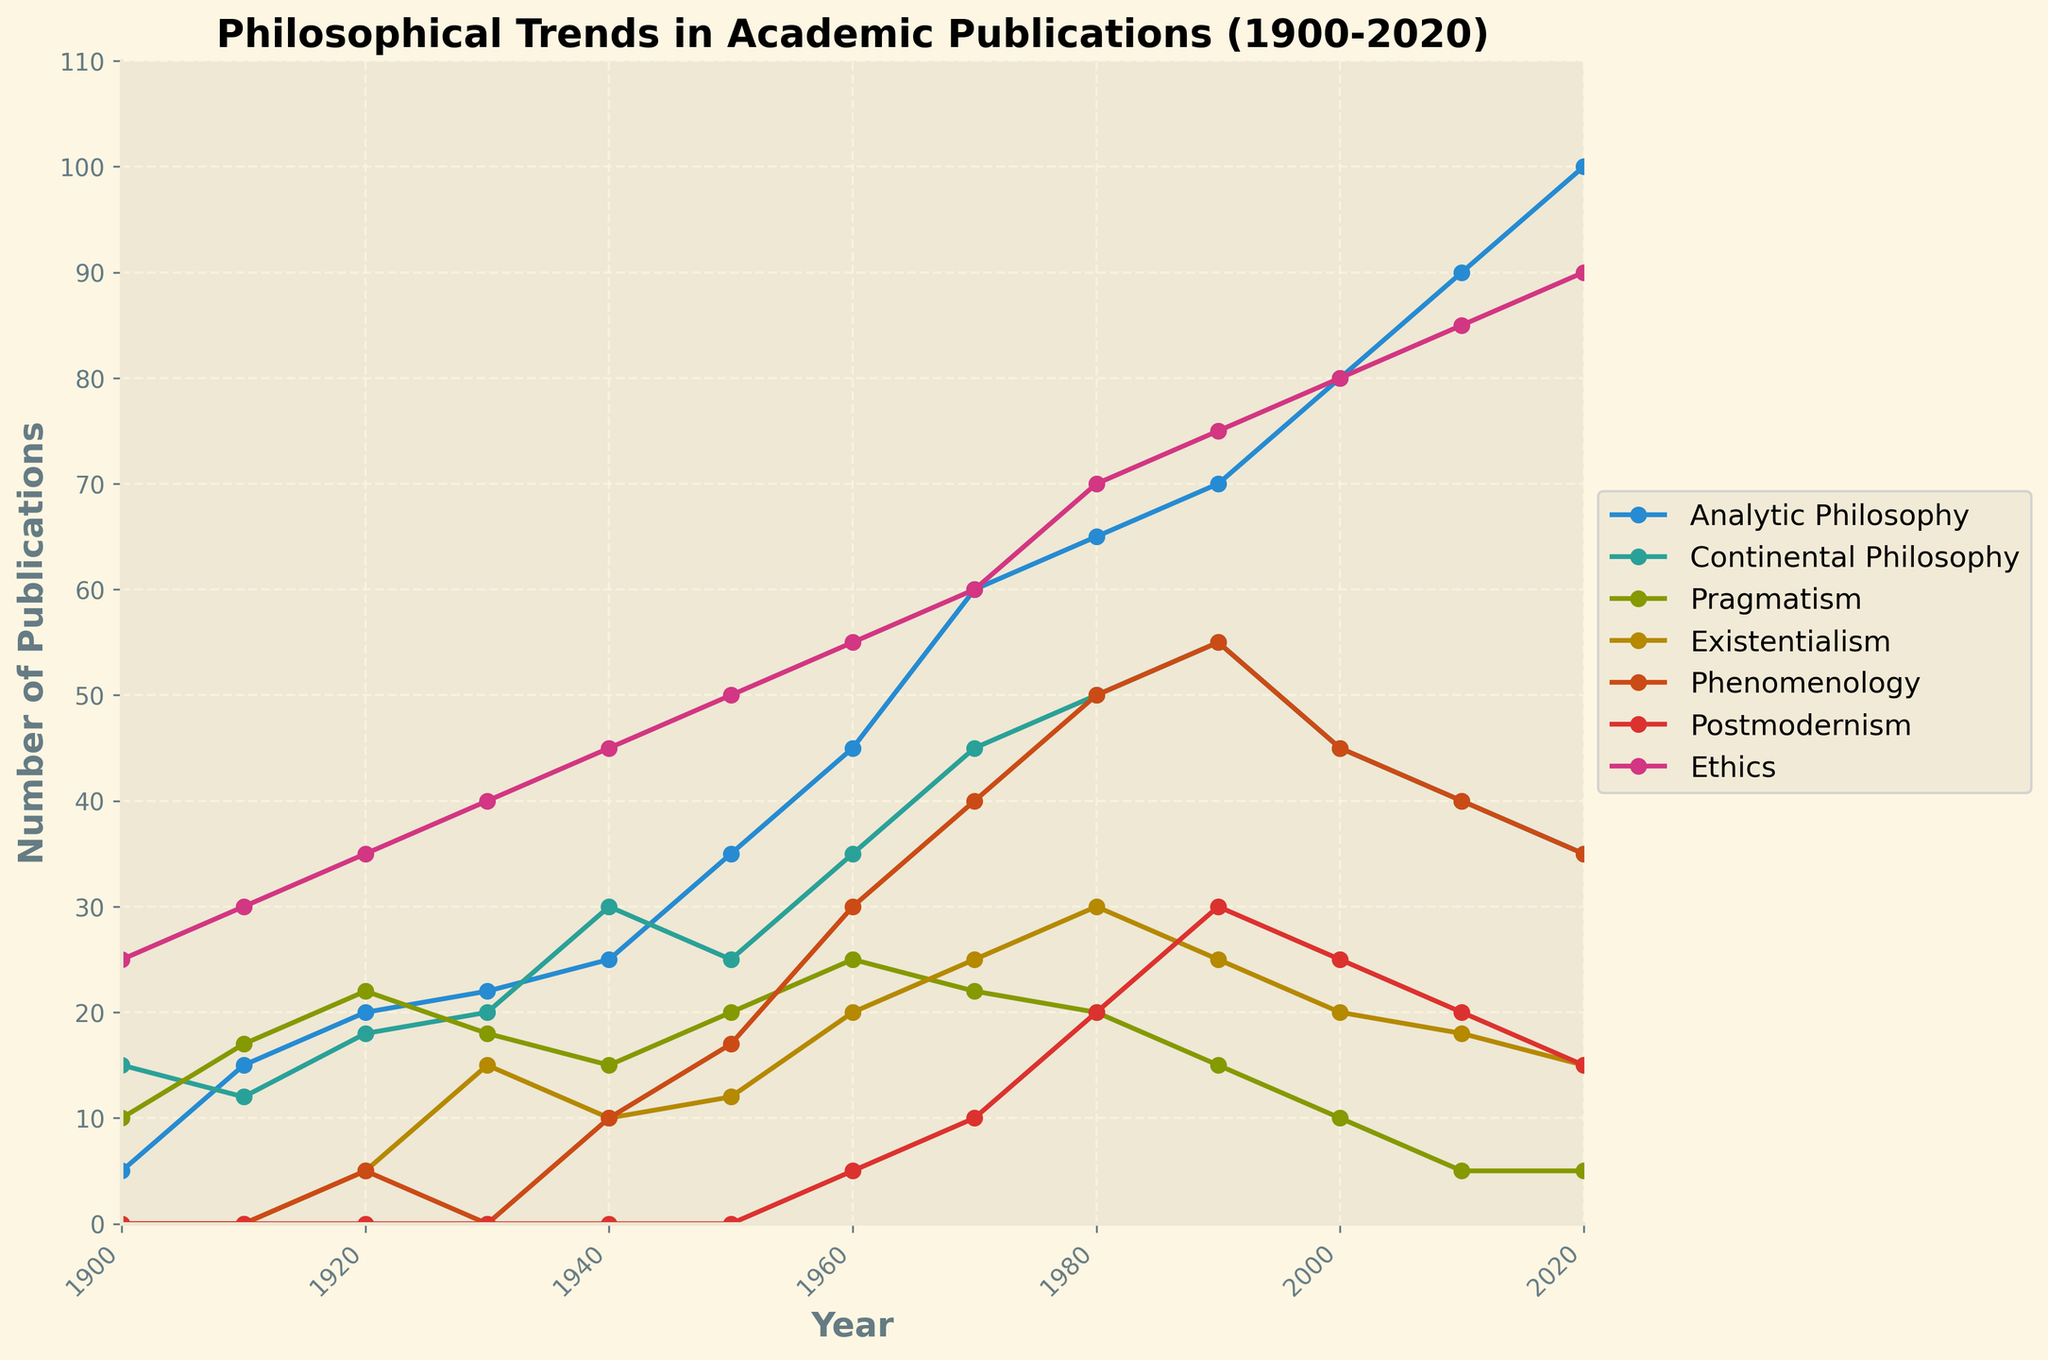what is the title of the plot? The title is typically located at the top of the figure and provides a summary of what the plot is about. The title of this plot is 'Philosophical Trends in Academic Publications (1900-2020)'
Answer: Philosophical Trends in Academic Publications (1900-2020) Which philosophical trend had the highest number of publications in 2000? Look for the data point for the year 2000 and identify the highest value among the trends. Analytic Philosophy had 80 publications, which is the highest.
Answer: Analytic Philosophy How has the number of publications in Pragmatism changed from 1910 to 2010? Compare the values for "Pragmatism" in the years 1910 and 2010. In 1910, Pragmatism had 17 publications, and by 2010, it dropped to 5 publications. The change is 17 - 5 = 12.
Answer: Decreased by 12 Which trend experienced the greatest increase in publications between 1960 and 1980? To identify this, calculate the difference between the publication numbers in 1980 and 1960 for each trend and determine the maximum increase. Analytic Philosophy increased from 45 to 65, which is the largest increase of 20 publications.
Answer: Analytic Philosophy When did Phenomenology first appear in academic publications? Identify the year when Phenomenology first shows a non-zero value. The earliest appearance of Phenomenology is in 1920 with 5 publications.
Answer: 1920 What is the total number of publications for Existentialism in the 20th century (1900-1999)? Sum the publication values for Existentialism from 1900 to 1990. Summing 0, 0, 5, 15, 10, 12, 20, 25, 30, 25 gives a total of 142.
Answer: 142 Which philosophical trend had the steadiest increase in publication numbers over the entire timeline? To determine this, look for the trend that consistently increases without major fluctuations. Analytic Philosophy shows a steady increase from 5 in 1900 to 100 in 2020.
Answer: Analytic Philosophy How many philosophical trends had a higher number of publications in 1940 than in 1930? Compare the publication numbers for each trend in 1930 and 1940. Continental Philosophy, Analytic Philosophy, Ethics, and Phenomenology all had higher numbers in 1940.
Answer: 4 trends What's the difference in the number of publications between Postmodernism and Ethics in 1990? Find the values for both trends in 1990 and calculate the difference. Postmodernism had 30 publications, and Ethics had 75, so the difference is 75 - 30 = 45.
Answer: 45 